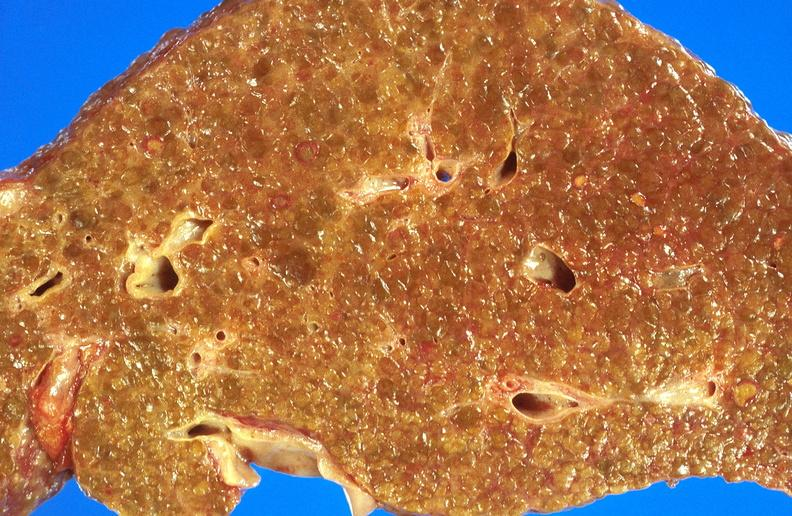s liver present?
Answer the question using a single word or phrase. Yes 